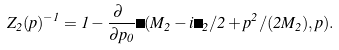<formula> <loc_0><loc_0><loc_500><loc_500>Z _ { 2 } ( p ) ^ { - 1 } = 1 - \frac { \partial \ } { \partial p _ { 0 } } \Sigma ( M _ { 2 } - i \Gamma _ { 2 } / 2 + p ^ { 2 } / ( 2 M _ { 2 } ) , p ) .</formula> 